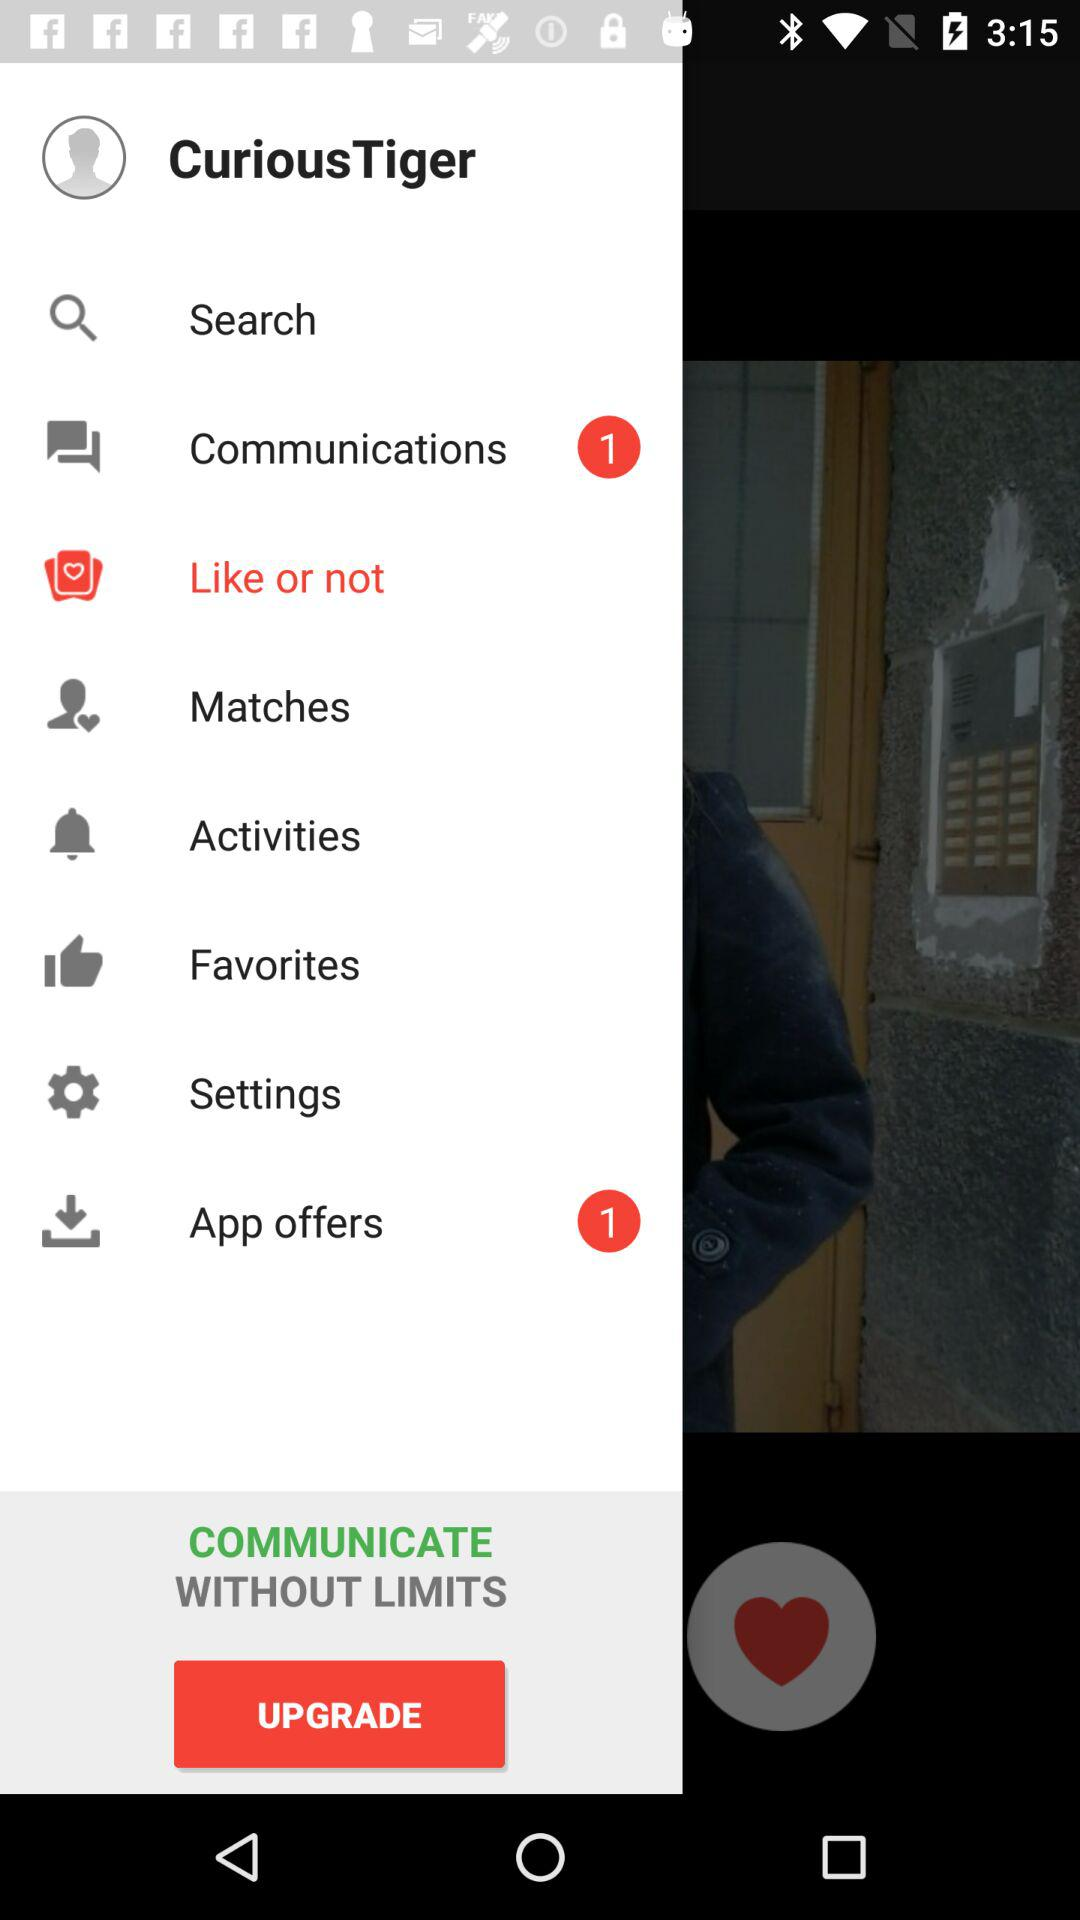How many unread chats in communications are there? There is 1 unread chat. 